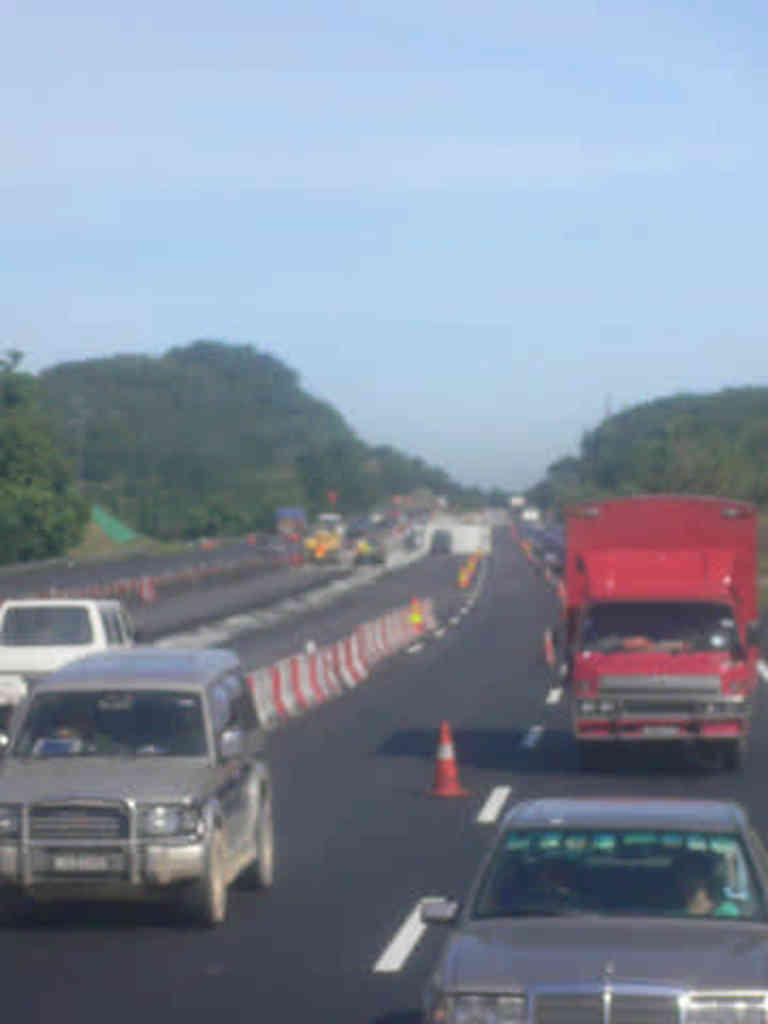What is the main feature of the image? There is a road in the image. What can be seen on the road? Traffic cones and dividers are visible on the road. What is the purpose of the traffic cones and dividers? The traffic cones and dividers are likely there to manage traffic flow and ensure safety. What else can be seen in the image? Vehicles are on the road, and there are trees around the road. What is the surrounding environment like? There are hills in the vicinity of the road. What type of metal is used to construct the society depicted in the image? There is no society depicted in the image; it is a road with traffic cones, dividers, vehicles, trees, and hills. 